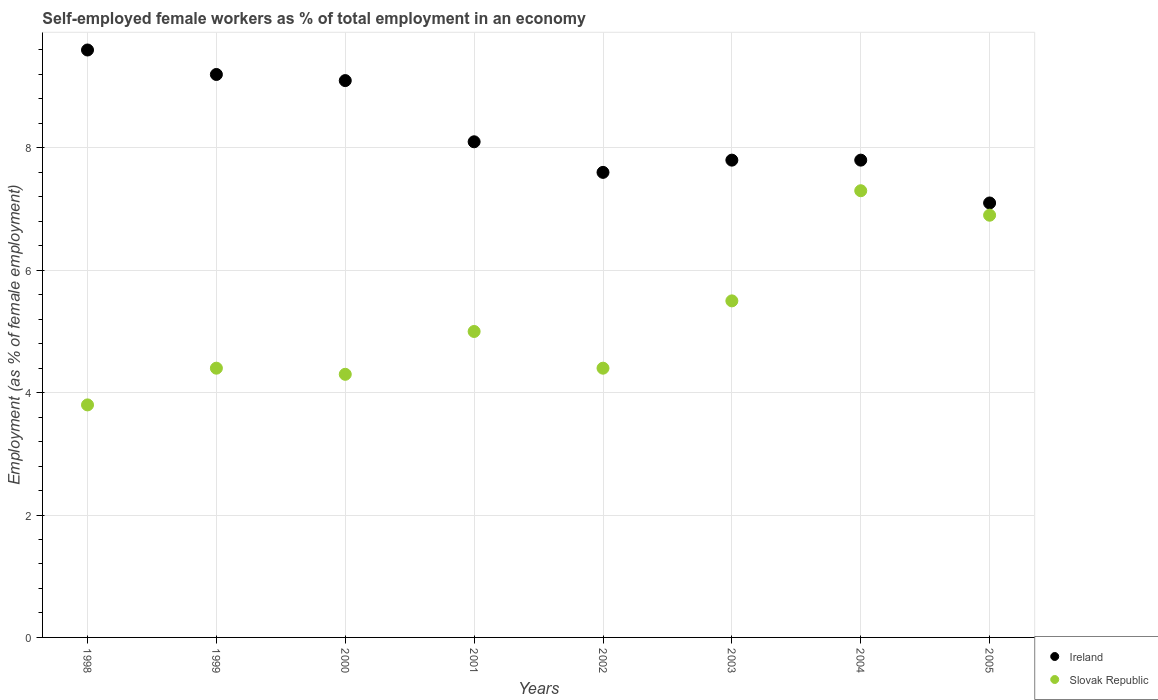What is the percentage of self-employed female workers in Slovak Republic in 2005?
Your answer should be compact. 6.9. Across all years, what is the maximum percentage of self-employed female workers in Ireland?
Your answer should be compact. 9.6. Across all years, what is the minimum percentage of self-employed female workers in Ireland?
Provide a short and direct response. 7.1. In which year was the percentage of self-employed female workers in Ireland maximum?
Keep it short and to the point. 1998. In which year was the percentage of self-employed female workers in Ireland minimum?
Your response must be concise. 2005. What is the total percentage of self-employed female workers in Ireland in the graph?
Your answer should be very brief. 66.3. What is the difference between the percentage of self-employed female workers in Ireland in 2002 and the percentage of self-employed female workers in Slovak Republic in 1999?
Give a very brief answer. 3.2. What is the average percentage of self-employed female workers in Ireland per year?
Your answer should be very brief. 8.29. What is the ratio of the percentage of self-employed female workers in Ireland in 2000 to that in 2001?
Give a very brief answer. 1.12. What is the difference between the highest and the second highest percentage of self-employed female workers in Ireland?
Keep it short and to the point. 0.4. What is the difference between the highest and the lowest percentage of self-employed female workers in Ireland?
Your answer should be very brief. 2.5. In how many years, is the percentage of self-employed female workers in Ireland greater than the average percentage of self-employed female workers in Ireland taken over all years?
Your response must be concise. 3. Is the sum of the percentage of self-employed female workers in Slovak Republic in 1998 and 2000 greater than the maximum percentage of self-employed female workers in Ireland across all years?
Keep it short and to the point. No. Does the percentage of self-employed female workers in Ireland monotonically increase over the years?
Offer a very short reply. No. Is the percentage of self-employed female workers in Ireland strictly greater than the percentage of self-employed female workers in Slovak Republic over the years?
Provide a short and direct response. Yes. How many dotlines are there?
Offer a terse response. 2. How many years are there in the graph?
Your answer should be very brief. 8. What is the difference between two consecutive major ticks on the Y-axis?
Provide a short and direct response. 2. Are the values on the major ticks of Y-axis written in scientific E-notation?
Your answer should be very brief. No. Does the graph contain grids?
Provide a short and direct response. Yes. How many legend labels are there?
Keep it short and to the point. 2. How are the legend labels stacked?
Offer a very short reply. Vertical. What is the title of the graph?
Provide a short and direct response. Self-employed female workers as % of total employment in an economy. What is the label or title of the X-axis?
Your answer should be compact. Years. What is the label or title of the Y-axis?
Make the answer very short. Employment (as % of female employment). What is the Employment (as % of female employment) in Ireland in 1998?
Provide a succinct answer. 9.6. What is the Employment (as % of female employment) in Slovak Republic in 1998?
Make the answer very short. 3.8. What is the Employment (as % of female employment) in Ireland in 1999?
Keep it short and to the point. 9.2. What is the Employment (as % of female employment) in Slovak Republic in 1999?
Your answer should be very brief. 4.4. What is the Employment (as % of female employment) of Ireland in 2000?
Provide a short and direct response. 9.1. What is the Employment (as % of female employment) in Slovak Republic in 2000?
Offer a terse response. 4.3. What is the Employment (as % of female employment) in Ireland in 2001?
Make the answer very short. 8.1. What is the Employment (as % of female employment) of Ireland in 2002?
Provide a short and direct response. 7.6. What is the Employment (as % of female employment) in Slovak Republic in 2002?
Make the answer very short. 4.4. What is the Employment (as % of female employment) in Ireland in 2003?
Give a very brief answer. 7.8. What is the Employment (as % of female employment) of Slovak Republic in 2003?
Make the answer very short. 5.5. What is the Employment (as % of female employment) of Ireland in 2004?
Make the answer very short. 7.8. What is the Employment (as % of female employment) of Slovak Republic in 2004?
Your response must be concise. 7.3. What is the Employment (as % of female employment) in Ireland in 2005?
Make the answer very short. 7.1. What is the Employment (as % of female employment) in Slovak Republic in 2005?
Give a very brief answer. 6.9. Across all years, what is the maximum Employment (as % of female employment) in Ireland?
Provide a succinct answer. 9.6. Across all years, what is the maximum Employment (as % of female employment) in Slovak Republic?
Give a very brief answer. 7.3. Across all years, what is the minimum Employment (as % of female employment) of Ireland?
Your response must be concise. 7.1. Across all years, what is the minimum Employment (as % of female employment) of Slovak Republic?
Offer a very short reply. 3.8. What is the total Employment (as % of female employment) of Ireland in the graph?
Keep it short and to the point. 66.3. What is the total Employment (as % of female employment) of Slovak Republic in the graph?
Give a very brief answer. 41.6. What is the difference between the Employment (as % of female employment) of Ireland in 1998 and that in 1999?
Offer a very short reply. 0.4. What is the difference between the Employment (as % of female employment) in Ireland in 1998 and that in 2000?
Offer a terse response. 0.5. What is the difference between the Employment (as % of female employment) in Ireland in 1998 and that in 2002?
Provide a succinct answer. 2. What is the difference between the Employment (as % of female employment) of Slovak Republic in 1998 and that in 2004?
Give a very brief answer. -3.5. What is the difference between the Employment (as % of female employment) in Slovak Republic in 1998 and that in 2005?
Give a very brief answer. -3.1. What is the difference between the Employment (as % of female employment) in Ireland in 1999 and that in 2000?
Ensure brevity in your answer.  0.1. What is the difference between the Employment (as % of female employment) of Slovak Republic in 1999 and that in 2000?
Ensure brevity in your answer.  0.1. What is the difference between the Employment (as % of female employment) in Ireland in 1999 and that in 2001?
Give a very brief answer. 1.1. What is the difference between the Employment (as % of female employment) of Slovak Republic in 1999 and that in 2001?
Offer a very short reply. -0.6. What is the difference between the Employment (as % of female employment) of Ireland in 1999 and that in 2002?
Your answer should be compact. 1.6. What is the difference between the Employment (as % of female employment) in Slovak Republic in 1999 and that in 2002?
Your answer should be compact. 0. What is the difference between the Employment (as % of female employment) in Ireland in 1999 and that in 2003?
Your response must be concise. 1.4. What is the difference between the Employment (as % of female employment) in Slovak Republic in 1999 and that in 2004?
Offer a terse response. -2.9. What is the difference between the Employment (as % of female employment) of Slovak Republic in 1999 and that in 2005?
Offer a terse response. -2.5. What is the difference between the Employment (as % of female employment) of Ireland in 2000 and that in 2001?
Your response must be concise. 1. What is the difference between the Employment (as % of female employment) in Slovak Republic in 2000 and that in 2001?
Offer a terse response. -0.7. What is the difference between the Employment (as % of female employment) in Ireland in 2000 and that in 2002?
Provide a short and direct response. 1.5. What is the difference between the Employment (as % of female employment) of Slovak Republic in 2000 and that in 2003?
Provide a succinct answer. -1.2. What is the difference between the Employment (as % of female employment) in Slovak Republic in 2000 and that in 2004?
Your answer should be compact. -3. What is the difference between the Employment (as % of female employment) in Ireland in 2000 and that in 2005?
Give a very brief answer. 2. What is the difference between the Employment (as % of female employment) in Ireland in 2001 and that in 2002?
Your answer should be very brief. 0.5. What is the difference between the Employment (as % of female employment) of Slovak Republic in 2001 and that in 2002?
Ensure brevity in your answer.  0.6. What is the difference between the Employment (as % of female employment) in Ireland in 2001 and that in 2003?
Provide a short and direct response. 0.3. What is the difference between the Employment (as % of female employment) of Slovak Republic in 2001 and that in 2003?
Ensure brevity in your answer.  -0.5. What is the difference between the Employment (as % of female employment) in Slovak Republic in 2001 and that in 2004?
Make the answer very short. -2.3. What is the difference between the Employment (as % of female employment) in Ireland in 2001 and that in 2005?
Give a very brief answer. 1. What is the difference between the Employment (as % of female employment) in Slovak Republic in 2001 and that in 2005?
Keep it short and to the point. -1.9. What is the difference between the Employment (as % of female employment) of Ireland in 2002 and that in 2003?
Offer a very short reply. -0.2. What is the difference between the Employment (as % of female employment) of Slovak Republic in 2002 and that in 2003?
Your answer should be compact. -1.1. What is the difference between the Employment (as % of female employment) in Slovak Republic in 2002 and that in 2004?
Your answer should be very brief. -2.9. What is the difference between the Employment (as % of female employment) in Ireland in 2002 and that in 2005?
Ensure brevity in your answer.  0.5. What is the difference between the Employment (as % of female employment) in Slovak Republic in 2002 and that in 2005?
Give a very brief answer. -2.5. What is the difference between the Employment (as % of female employment) in Ireland in 2003 and that in 2004?
Your answer should be compact. 0. What is the difference between the Employment (as % of female employment) of Slovak Republic in 2004 and that in 2005?
Provide a short and direct response. 0.4. What is the difference between the Employment (as % of female employment) in Ireland in 1998 and the Employment (as % of female employment) in Slovak Republic in 2002?
Your answer should be compact. 5.2. What is the difference between the Employment (as % of female employment) of Ireland in 1998 and the Employment (as % of female employment) of Slovak Republic in 2004?
Offer a very short reply. 2.3. What is the difference between the Employment (as % of female employment) of Ireland in 2000 and the Employment (as % of female employment) of Slovak Republic in 2001?
Ensure brevity in your answer.  4.1. What is the difference between the Employment (as % of female employment) of Ireland in 2000 and the Employment (as % of female employment) of Slovak Republic in 2003?
Offer a terse response. 3.6. What is the difference between the Employment (as % of female employment) in Ireland in 2000 and the Employment (as % of female employment) in Slovak Republic in 2005?
Provide a short and direct response. 2.2. What is the difference between the Employment (as % of female employment) in Ireland in 2001 and the Employment (as % of female employment) in Slovak Republic in 2002?
Offer a terse response. 3.7. What is the difference between the Employment (as % of female employment) of Ireland in 2001 and the Employment (as % of female employment) of Slovak Republic in 2003?
Provide a succinct answer. 2.6. What is the difference between the Employment (as % of female employment) in Ireland in 2001 and the Employment (as % of female employment) in Slovak Republic in 2004?
Offer a terse response. 0.8. What is the difference between the Employment (as % of female employment) of Ireland in 2001 and the Employment (as % of female employment) of Slovak Republic in 2005?
Your response must be concise. 1.2. What is the difference between the Employment (as % of female employment) in Ireland in 2002 and the Employment (as % of female employment) in Slovak Republic in 2005?
Offer a terse response. 0.7. What is the difference between the Employment (as % of female employment) in Ireland in 2003 and the Employment (as % of female employment) in Slovak Republic in 2004?
Your answer should be compact. 0.5. What is the difference between the Employment (as % of female employment) of Ireland in 2004 and the Employment (as % of female employment) of Slovak Republic in 2005?
Offer a terse response. 0.9. What is the average Employment (as % of female employment) in Ireland per year?
Give a very brief answer. 8.29. What is the average Employment (as % of female employment) in Slovak Republic per year?
Your answer should be compact. 5.2. In the year 1999, what is the difference between the Employment (as % of female employment) in Ireland and Employment (as % of female employment) in Slovak Republic?
Provide a short and direct response. 4.8. In the year 2001, what is the difference between the Employment (as % of female employment) in Ireland and Employment (as % of female employment) in Slovak Republic?
Offer a terse response. 3.1. In the year 2002, what is the difference between the Employment (as % of female employment) in Ireland and Employment (as % of female employment) in Slovak Republic?
Your answer should be very brief. 3.2. In the year 2003, what is the difference between the Employment (as % of female employment) of Ireland and Employment (as % of female employment) of Slovak Republic?
Provide a succinct answer. 2.3. What is the ratio of the Employment (as % of female employment) of Ireland in 1998 to that in 1999?
Keep it short and to the point. 1.04. What is the ratio of the Employment (as % of female employment) of Slovak Republic in 1998 to that in 1999?
Provide a short and direct response. 0.86. What is the ratio of the Employment (as % of female employment) of Ireland in 1998 to that in 2000?
Keep it short and to the point. 1.05. What is the ratio of the Employment (as % of female employment) of Slovak Republic in 1998 to that in 2000?
Give a very brief answer. 0.88. What is the ratio of the Employment (as % of female employment) of Ireland in 1998 to that in 2001?
Provide a short and direct response. 1.19. What is the ratio of the Employment (as % of female employment) of Slovak Republic in 1998 to that in 2001?
Your answer should be very brief. 0.76. What is the ratio of the Employment (as % of female employment) of Ireland in 1998 to that in 2002?
Your response must be concise. 1.26. What is the ratio of the Employment (as % of female employment) of Slovak Republic in 1998 to that in 2002?
Your answer should be compact. 0.86. What is the ratio of the Employment (as % of female employment) of Ireland in 1998 to that in 2003?
Offer a very short reply. 1.23. What is the ratio of the Employment (as % of female employment) in Slovak Republic in 1998 to that in 2003?
Provide a succinct answer. 0.69. What is the ratio of the Employment (as % of female employment) of Ireland in 1998 to that in 2004?
Your response must be concise. 1.23. What is the ratio of the Employment (as % of female employment) of Slovak Republic in 1998 to that in 2004?
Ensure brevity in your answer.  0.52. What is the ratio of the Employment (as % of female employment) in Ireland in 1998 to that in 2005?
Provide a short and direct response. 1.35. What is the ratio of the Employment (as % of female employment) of Slovak Republic in 1998 to that in 2005?
Offer a terse response. 0.55. What is the ratio of the Employment (as % of female employment) of Slovak Republic in 1999 to that in 2000?
Provide a succinct answer. 1.02. What is the ratio of the Employment (as % of female employment) in Ireland in 1999 to that in 2001?
Provide a succinct answer. 1.14. What is the ratio of the Employment (as % of female employment) of Ireland in 1999 to that in 2002?
Provide a succinct answer. 1.21. What is the ratio of the Employment (as % of female employment) of Slovak Republic in 1999 to that in 2002?
Your answer should be compact. 1. What is the ratio of the Employment (as % of female employment) of Ireland in 1999 to that in 2003?
Keep it short and to the point. 1.18. What is the ratio of the Employment (as % of female employment) of Ireland in 1999 to that in 2004?
Your answer should be compact. 1.18. What is the ratio of the Employment (as % of female employment) of Slovak Republic in 1999 to that in 2004?
Make the answer very short. 0.6. What is the ratio of the Employment (as % of female employment) in Ireland in 1999 to that in 2005?
Provide a succinct answer. 1.3. What is the ratio of the Employment (as % of female employment) of Slovak Republic in 1999 to that in 2005?
Give a very brief answer. 0.64. What is the ratio of the Employment (as % of female employment) in Ireland in 2000 to that in 2001?
Your answer should be compact. 1.12. What is the ratio of the Employment (as % of female employment) of Slovak Republic in 2000 to that in 2001?
Ensure brevity in your answer.  0.86. What is the ratio of the Employment (as % of female employment) of Ireland in 2000 to that in 2002?
Provide a short and direct response. 1.2. What is the ratio of the Employment (as % of female employment) in Slovak Republic in 2000 to that in 2002?
Make the answer very short. 0.98. What is the ratio of the Employment (as % of female employment) in Slovak Republic in 2000 to that in 2003?
Keep it short and to the point. 0.78. What is the ratio of the Employment (as % of female employment) of Ireland in 2000 to that in 2004?
Provide a succinct answer. 1.17. What is the ratio of the Employment (as % of female employment) in Slovak Republic in 2000 to that in 2004?
Give a very brief answer. 0.59. What is the ratio of the Employment (as % of female employment) in Ireland in 2000 to that in 2005?
Provide a short and direct response. 1.28. What is the ratio of the Employment (as % of female employment) of Slovak Republic in 2000 to that in 2005?
Provide a short and direct response. 0.62. What is the ratio of the Employment (as % of female employment) of Ireland in 2001 to that in 2002?
Make the answer very short. 1.07. What is the ratio of the Employment (as % of female employment) of Slovak Republic in 2001 to that in 2002?
Give a very brief answer. 1.14. What is the ratio of the Employment (as % of female employment) in Slovak Republic in 2001 to that in 2003?
Your answer should be compact. 0.91. What is the ratio of the Employment (as % of female employment) of Ireland in 2001 to that in 2004?
Provide a succinct answer. 1.04. What is the ratio of the Employment (as % of female employment) of Slovak Republic in 2001 to that in 2004?
Your answer should be compact. 0.68. What is the ratio of the Employment (as % of female employment) of Ireland in 2001 to that in 2005?
Keep it short and to the point. 1.14. What is the ratio of the Employment (as % of female employment) in Slovak Republic in 2001 to that in 2005?
Keep it short and to the point. 0.72. What is the ratio of the Employment (as % of female employment) of Ireland in 2002 to that in 2003?
Make the answer very short. 0.97. What is the ratio of the Employment (as % of female employment) of Slovak Republic in 2002 to that in 2003?
Your answer should be compact. 0.8. What is the ratio of the Employment (as % of female employment) in Ireland in 2002 to that in 2004?
Make the answer very short. 0.97. What is the ratio of the Employment (as % of female employment) of Slovak Republic in 2002 to that in 2004?
Make the answer very short. 0.6. What is the ratio of the Employment (as % of female employment) of Ireland in 2002 to that in 2005?
Your response must be concise. 1.07. What is the ratio of the Employment (as % of female employment) of Slovak Republic in 2002 to that in 2005?
Your answer should be very brief. 0.64. What is the ratio of the Employment (as % of female employment) of Ireland in 2003 to that in 2004?
Offer a terse response. 1. What is the ratio of the Employment (as % of female employment) in Slovak Republic in 2003 to that in 2004?
Provide a short and direct response. 0.75. What is the ratio of the Employment (as % of female employment) in Ireland in 2003 to that in 2005?
Give a very brief answer. 1.1. What is the ratio of the Employment (as % of female employment) of Slovak Republic in 2003 to that in 2005?
Keep it short and to the point. 0.8. What is the ratio of the Employment (as % of female employment) in Ireland in 2004 to that in 2005?
Offer a terse response. 1.1. What is the ratio of the Employment (as % of female employment) of Slovak Republic in 2004 to that in 2005?
Provide a succinct answer. 1.06. What is the difference between the highest and the second highest Employment (as % of female employment) in Ireland?
Provide a short and direct response. 0.4. What is the difference between the highest and the lowest Employment (as % of female employment) of Slovak Republic?
Ensure brevity in your answer.  3.5. 